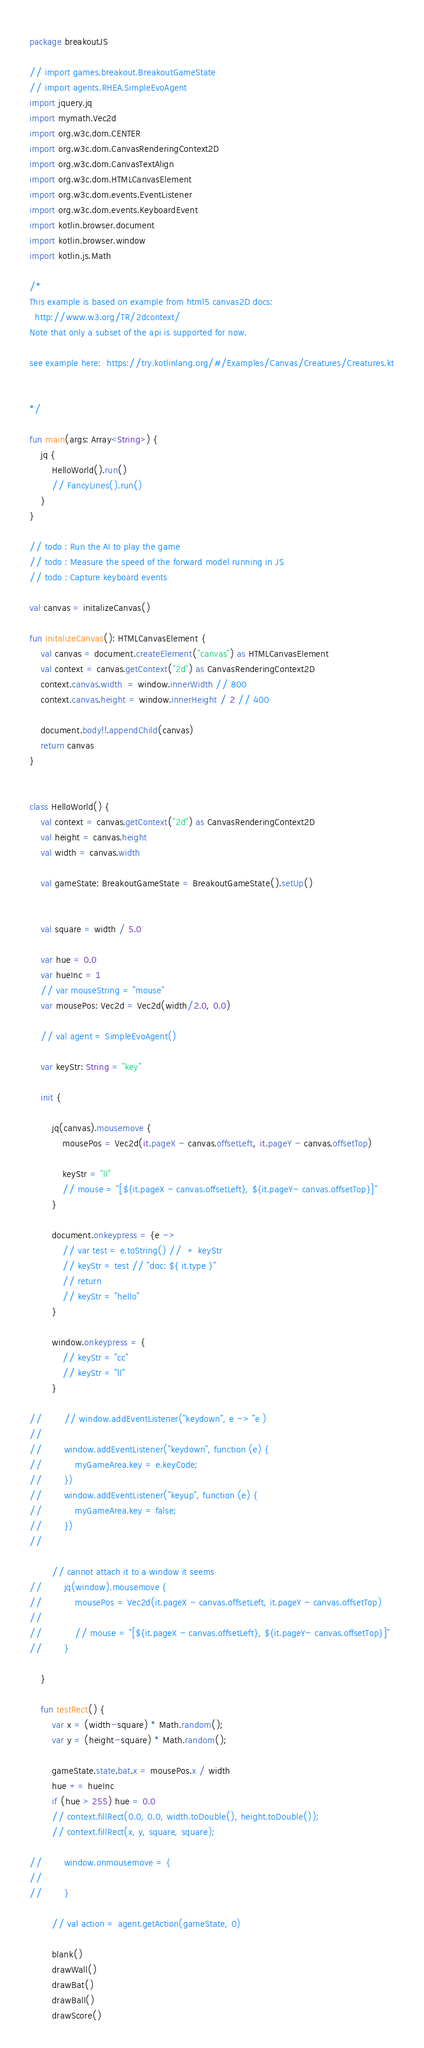<code> <loc_0><loc_0><loc_500><loc_500><_Kotlin_>package breakoutJS

// import games.breakout.BreakoutGameState
// import agents.RHEA.SimpleEvoAgent
import jquery.jq
import mymath.Vec2d
import org.w3c.dom.CENTER
import org.w3c.dom.CanvasRenderingContext2D
import org.w3c.dom.CanvasTextAlign
import org.w3c.dom.HTMLCanvasElement
import org.w3c.dom.events.EventListener
import org.w3c.dom.events.KeyboardEvent
import kotlin.browser.document
import kotlin.browser.window
import kotlin.js.Math

/*
This example is based on example from html5 canvas2D docs:
  http://www.w3.org/TR/2dcontext/
Note that only a subset of the api is supported for now.

see example here:  https://try.kotlinlang.org/#/Examples/Canvas/Creatures/Creatures.kt


*/

fun main(args: Array<String>) {
    jq {
        HelloWorld().run()
        // FancyLines().run()
    }
}

// todo : Run the AI to play the game
// todo : Measure the speed of the forward model running in JS
// todo : Capture keyboard events

val canvas = initalizeCanvas()

fun initalizeCanvas(): HTMLCanvasElement {
    val canvas = document.createElement("canvas") as HTMLCanvasElement
    val context = canvas.getContext("2d") as CanvasRenderingContext2D
    context.canvas.width  = window.innerWidth // 800
    context.canvas.height = window.innerHeight / 2 // 400

    document.body!!.appendChild(canvas)
    return canvas
}


class HelloWorld() {
    val context = canvas.getContext("2d") as CanvasRenderingContext2D
    val height = canvas.height
    val width = canvas.width

    val gameState: BreakoutGameState = BreakoutGameState().setUp()


    val square = width / 5.0

    var hue = 0.0
    var hueInc = 1
    // var mouseString = "mouse"
    var mousePos: Vec2d = Vec2d(width/2.0, 0.0)

    // val agent = SimpleEvoAgent()

    var keyStr: String = "key"

    init {

        jq(canvas).mousemove {
            mousePos = Vec2d(it.pageX - canvas.offsetLeft, it.pageY - canvas.offsetTop)

            keyStr = "ll"
            // mouse = "[${it.pageX - canvas.offsetLeft}, ${it.pageY- canvas.offsetTop}]"
        }

        document.onkeypress = {e ->
            // var test = e.toString() //  + keyStr
            // keyStr = test // "doc: ${ it.type }"
            // return
            // keyStr = "hello"
        }

        window.onkeypress = {
            // keyStr = "cc"
            // keyStr = "ll"
        }

//        // window.addEventListener("keydown", e -> "e )
//
//        window.addEventListener("keydown", function (e) {
//            myGameArea.key = e.keyCode;
//        })
//        window.addEventListener("keyup", function (e) {
//            myGameArea.key = false;
//        })
//

        // cannot attach it to a window it seems
//        jq(window).mousemove {
//            mousePos = Vec2d(it.pageX - canvas.offsetLeft, it.pageY - canvas.offsetTop)
//
//            // mouse = "[${it.pageX - canvas.offsetLeft}, ${it.pageY- canvas.offsetTop}]"
//        }

    }

    fun testRect() {
        var x = (width-square) * Math.random();
        var y = (height-square) * Math.random();

        gameState.state.bat.x = mousePos.x / width
        hue += hueInc
        if (hue > 255) hue = 0.0
        // context.fillRect(0.0, 0.0, width.toDouble(), height.toDouble());
        // context.fillRect(x, y, square, square);

//        window.onmousemove = {
//
//        }

        // val action = agent.getAction(gameState, 0)

        blank()
        drawWall()
        drawBat()
        drawBall()
        drawScore()
</code> 